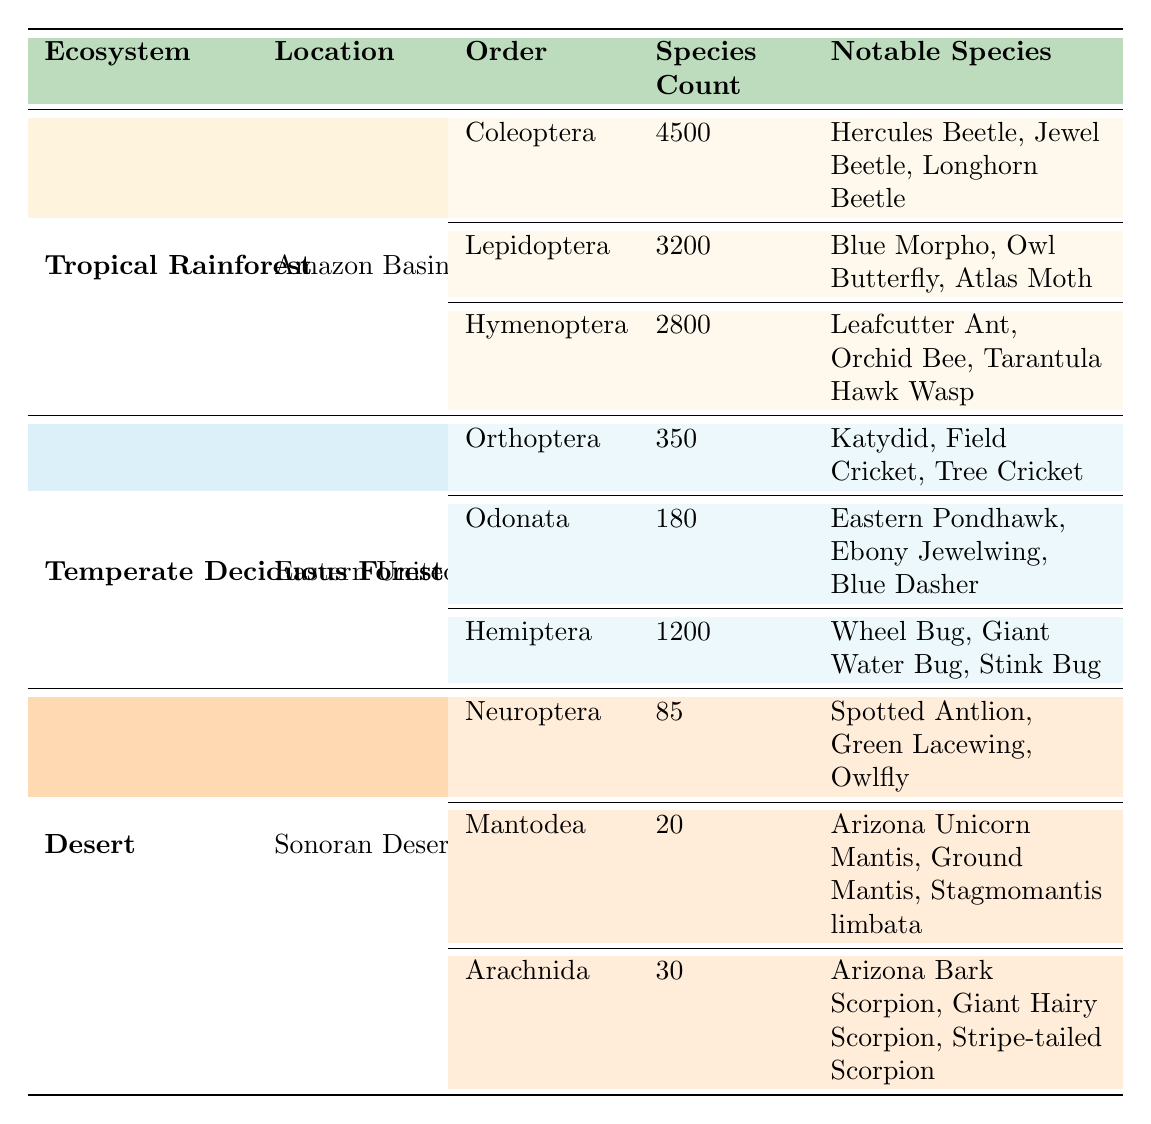What is the total number of insect species in the Tropical Rainforest? To find the total number of insect species, I will sum the species counts for the orders in the Tropical Rainforest. The counts are: Coleoptera (4500), Lepidoptera (3200), and Hymenoptera (2800). The total is 4500 + 3200 + 2800 = 10500.
Answer: 10500 Which ecosystem has the highest number of insect species? I will compare the total species counts for each ecosystem. Tropical Rainforest has 10500, Temperate Deciduous Forest has (350 + 180 + 1200 = 1730), and Desert has (85 + 20 + 30 = 135). The highest is 10500 in the Tropical Rainforest.
Answer: Tropical Rainforest Are scorpions considered insects in this table? The table includes a row for Arachnida, which contains scorpions, and specifies they are not insects but are included for interest. Hence, scorpions are not classified as insects in this context.
Answer: No What is the average number of species across all insect orders in the Temperate Deciduous Forest? In the Temperate Deciduous Forest, the species counts are: Orthoptera (350), Odonata (180), and Hemiptera (1200). I will sum these values: 350 + 180 + 1200 = 1730. There are 3 orders, so the average is 1730/3 = 576.67.
Answer: 576.67 How many more species of insects are there in the Tropical Rainforest compared to the Desert? I first find the total species in each ecosystem. The Tropical Rainforest has 10500 species, and the Desert has (85 + 20 + 30 = 135) species. The difference is 10500 - 135 = 10365.
Answer: 10365 Which notable species belong to the Lepidoptera order in the Tropical Rainforest? The notable species listed under the Lepidoptera order in the Tropical Rainforest are: Blue Morpho, Owl Butterfly, and Atlas Moth.
Answer: Blue Morpho, Owl Butterfly, Atlas Moth Is the number of beetle species in the Tropical Rainforest greater than the total number of species in both the Temperate Deciduous Forest and the Desert combined? The number of beetle species (Coleoptera) in the Tropical Rainforest is 4500. The total from the Temperate Deciduous Forest is 1730 and the Desert is 135, summing them gives 1730 + 135 = 1865. Since 4500 > 1865, it confirms the statement.
Answer: Yes What insect order in the Desert has the least number of species? In the Desert, the species counts for the orders are: Neuroptera (85), Mantodea (20), and Arachnida (30). The smallest count is for Mantodea with 20 species.
Answer: Mantodea What is the highest number of species found in a single order in all ecosystems? I will compare the highest counts across all orders: Coleoptera (4500), Hemiptera (1200), and Neuroptera (85). The highest is 4500 from the Coleoptera order in the Tropical Rainforest.
Answer: Coleoptera What notable species are associated with the Hymenoptera order? The notable species listed under the Hymenoptera order in the Tropical Rainforest are: Leafcutter Ant, Orchid Bee, and Tarantula Hawk Wasp.
Answer: Leafcutter Ant, Orchid Bee, Tarantula Hawk Wasp 